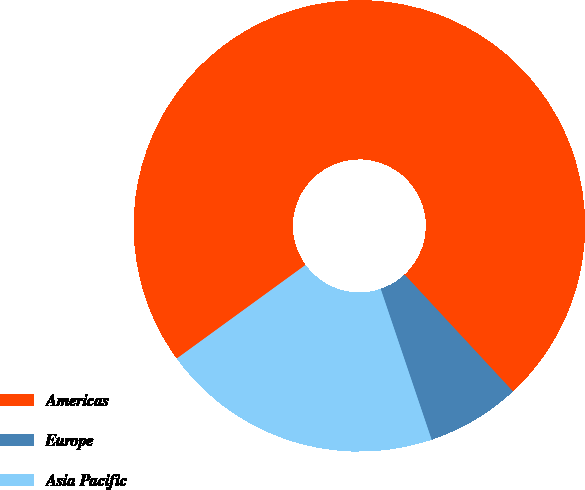<chart> <loc_0><loc_0><loc_500><loc_500><pie_chart><fcel>Americas<fcel>Europe<fcel>Asia Pacific<nl><fcel>73.1%<fcel>6.72%<fcel>20.18%<nl></chart> 